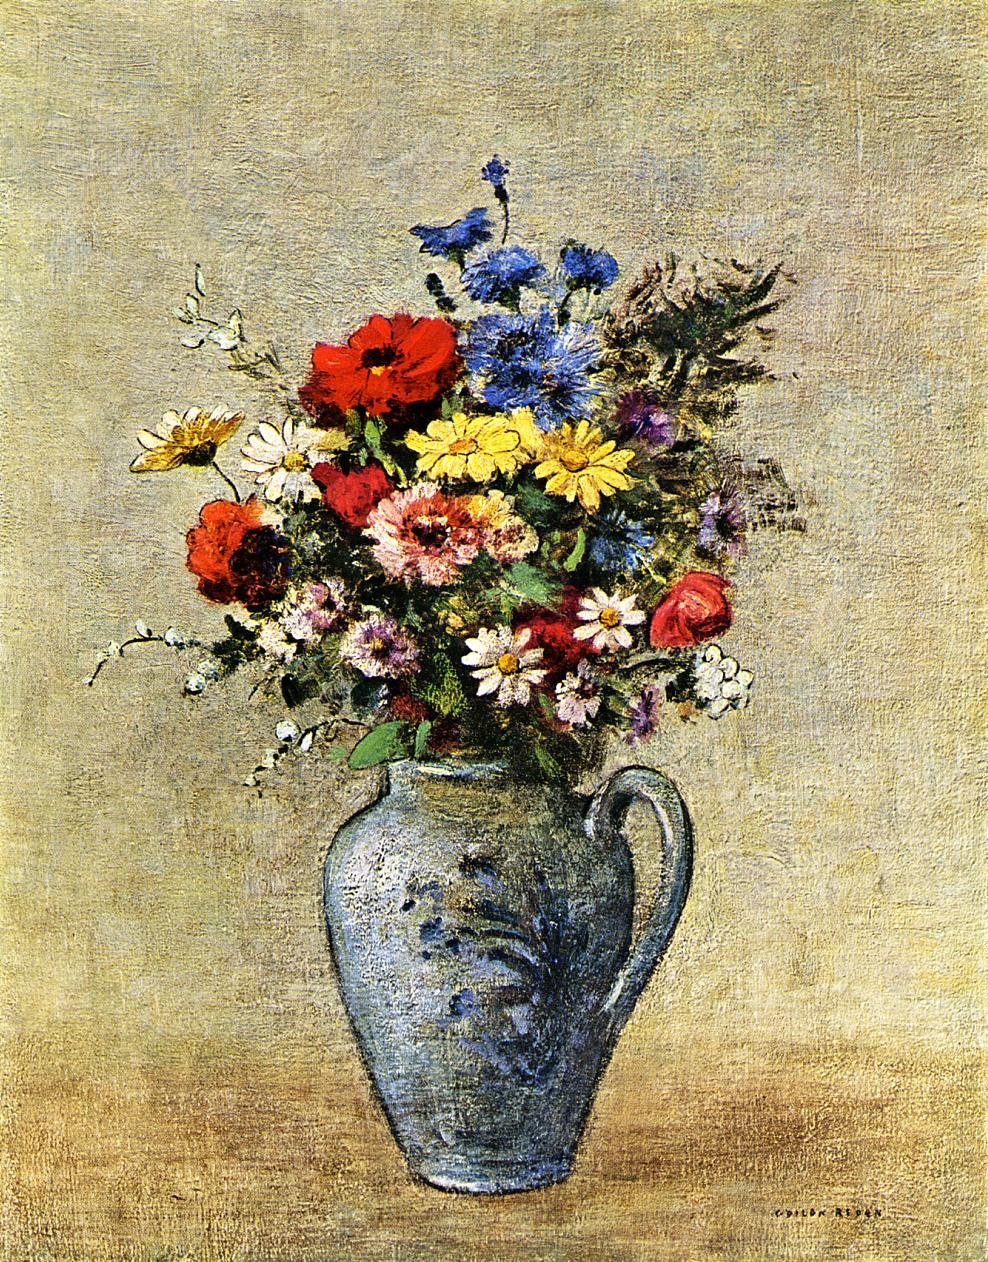Can you speculate about the time of year this painting might represent? The painting could represent late spring to early summer, suggested by the presence of both fully bloomed and budding flowers in various colors typically seen during these seasons. The choice of flowers like poppies, daisies, and possibly cornflowers also indicates this time period, resonating with the season of rebirth and abundant growth. 